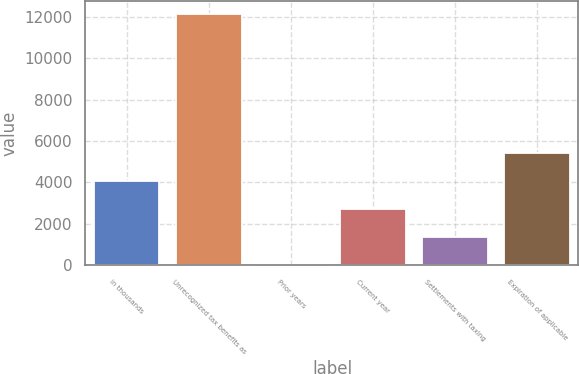Convert chart. <chart><loc_0><loc_0><loc_500><loc_500><bar_chart><fcel>in thousands<fcel>Unrecognized tax benefits as<fcel>Prior years<fcel>Current year<fcel>Settlements with taxing<fcel>Expiration of applicable<nl><fcel>4084.6<fcel>12155<fcel>28<fcel>2732.4<fcel>1380.2<fcel>5436.8<nl></chart> 